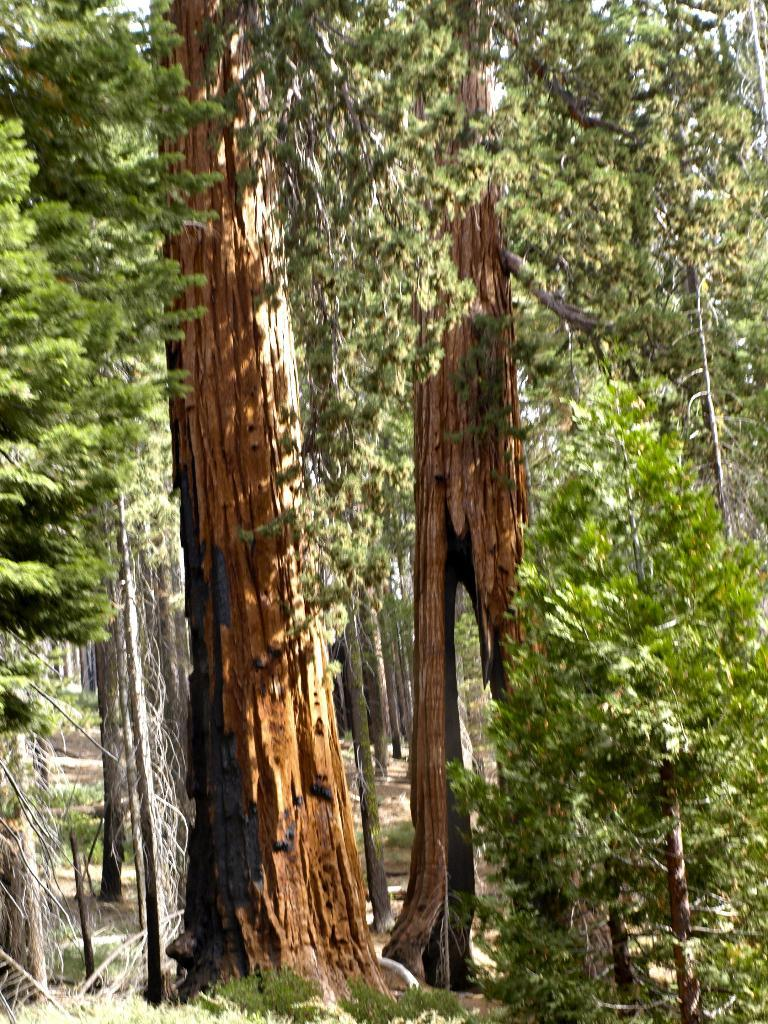What type of vegetation can be seen in the image? There are trees and grass in the image. Can you describe the natural environment depicted in the image? The image features trees and grass, which are common elements of natural landscapes. What type of wound can be seen on the tree in the image? There is no wound visible on any tree in the image. What type of learning is taking place in the image? There is no learning activity depicted in the image; it features trees and grass. 